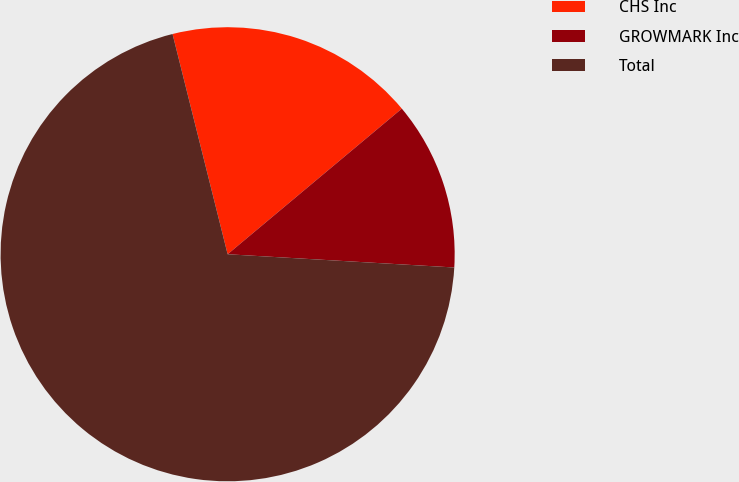Convert chart. <chart><loc_0><loc_0><loc_500><loc_500><pie_chart><fcel>CHS Inc<fcel>GROWMARK Inc<fcel>Total<nl><fcel>17.82%<fcel>12.01%<fcel>70.17%<nl></chart> 